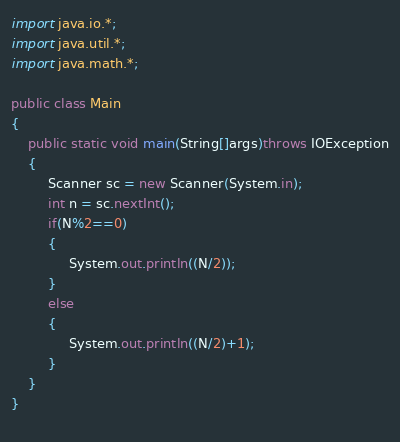Convert code to text. <code><loc_0><loc_0><loc_500><loc_500><_Java_>import java.io.*;
import java.util.*;
import java.math.*;

public class Main
{
    public static void main(String[]args)throws IOException
    {
         Scanner sc = new Scanner(System.in);
         int n = sc.nextInt();
         if(N%2==0)
         {
              System.out.println((N/2));
         }
         else
         {
              System.out.println((N/2)+1);
         }
    }
}
           </code> 